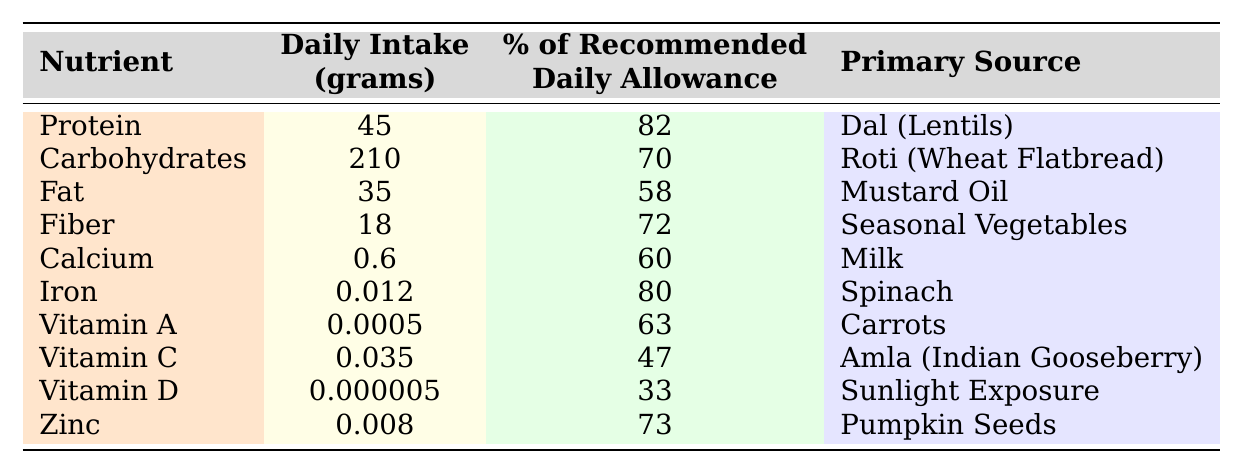What is the daily intake of protein for elderly pension recipients? According to the table, the daily intake of protein is listed as 45 grams.
Answer: 45 grams Which nutrient has the highest percentage of the recommended daily allowance? By examining the table, protein has 82% of the recommended daily allowance, which is the highest among the listed nutrients.
Answer: Protein How much daily intake of fat is there compared to carbohydrates? The table indicates that fat intake is 35 grams and carbohydrate intake is 210 grams. To compare, we note that carbohydrates significantly exceed fat in daily intake.
Answer: 35 grams (fat) vs. 210 grams (carbohydrates) What is the primary source of carbohydrates? The table specifies that the primary source of carbohydrates for the elderly pension recipients is Roti (Wheat Flatbread).
Answer: Roti (Wheat Flatbread) Is the intake of Vitamin C higher than the intake of Vitamin A? According to the table, Vitamin C intake is 0.035 grams while Vitamin A is 0.0005 grams. Since 0.035 is greater than 0.0005, Vitamin C intake is indeed higher.
Answer: Yes What are the total grams of fiber and protein combined? The daily intake of fiber is 18 grams and protein is 45 grams. Adding these two values together gives 18 grams + 45 grams = 63 grams as the total.
Answer: 63 grams Does the table indicate that calcium intake is sufficient according to the recommended daily allowance? The table shows that calcium intake is 0.6 grams with 60% of the recommended daily allowance. Since this indicates adequacy, we can conclude that the intake is considered sufficient.
Answer: Yes What nutrient constitutes the primary source of zinc in the diet? The table indicates that the primary source of zinc is pumpkin seeds.
Answer: Pumpkin Seeds If a pension recipient consumes the recommended amounts of protein, carbohydrates, and fat, what would be their total daily intake from these three nutrients? The table lists protein at 45 grams, carbohydrates at 210 grams, and fat at 35 grams. Adding these together gives 45 + 210 + 35 = 290 grams as the total daily intake from these three nutrients.
Answer: 290 grams Which vitamin has the lowest daily intake from the table? The values for Vitamin A, C, and D are all significantly low, but Vitamin D has the lowest recorded intake of 0.000005 grams when compared.
Answer: Vitamin D 